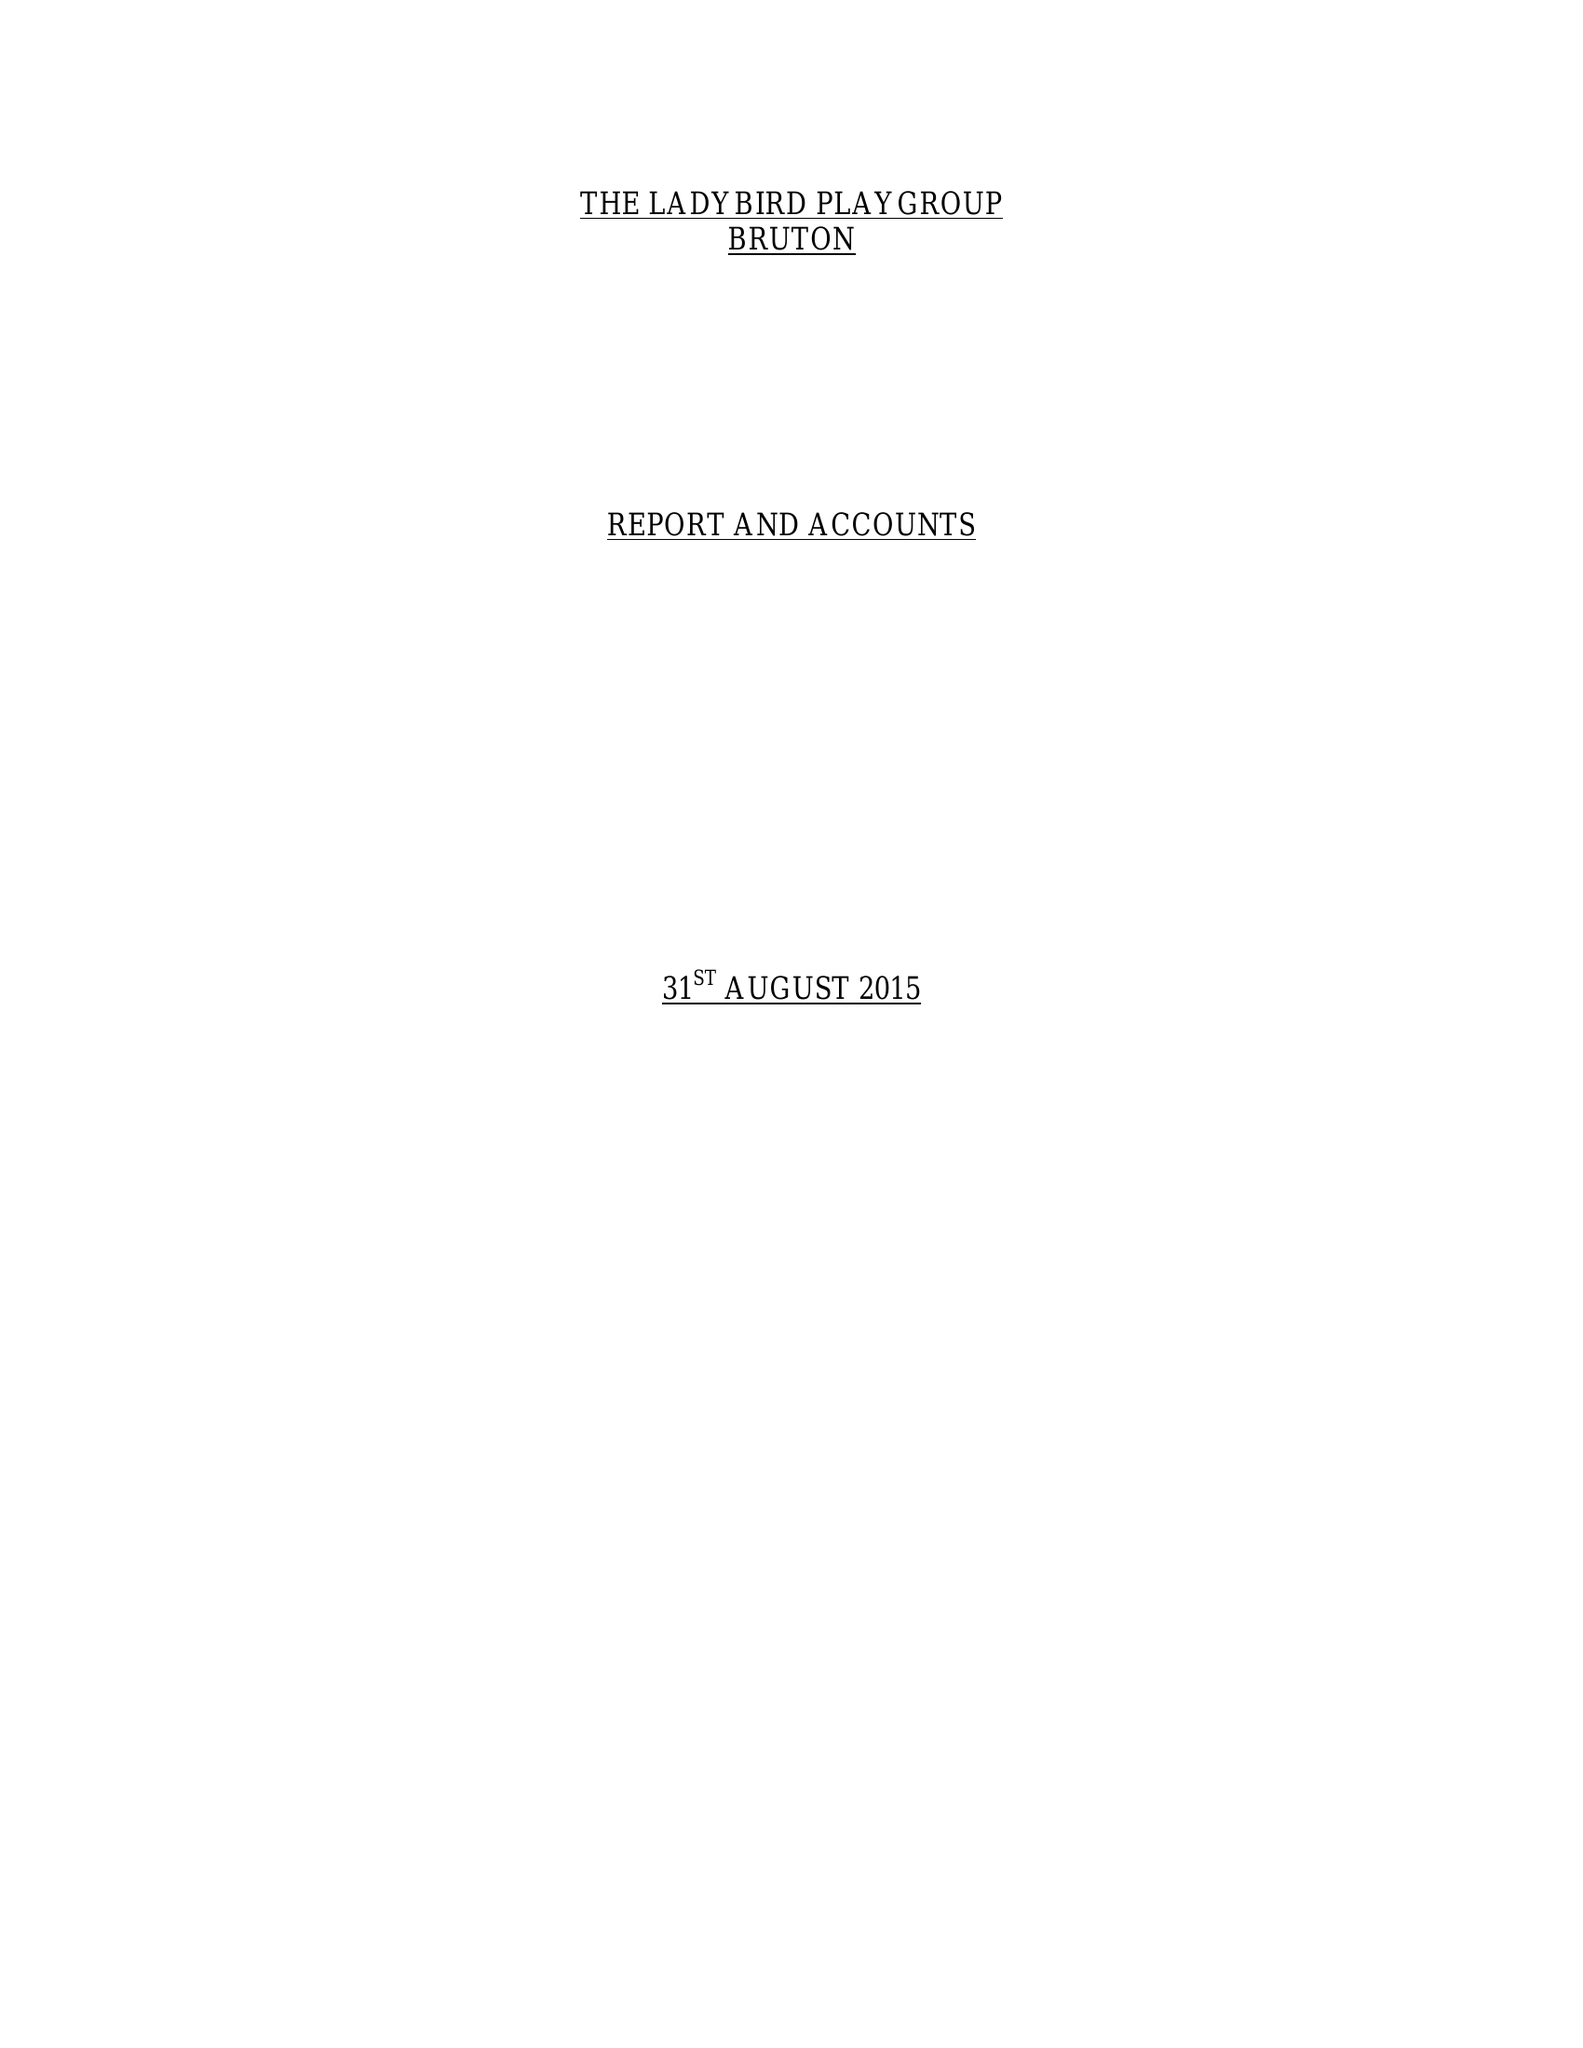What is the value for the income_annually_in_british_pounds?
Answer the question using a single word or phrase. 70352.35 